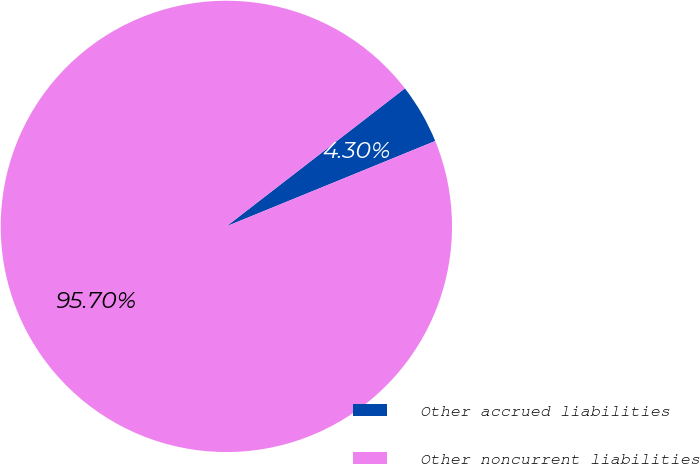<chart> <loc_0><loc_0><loc_500><loc_500><pie_chart><fcel>Other accrued liabilities<fcel>Other noncurrent liabilities<nl><fcel>4.3%<fcel>95.7%<nl></chart> 